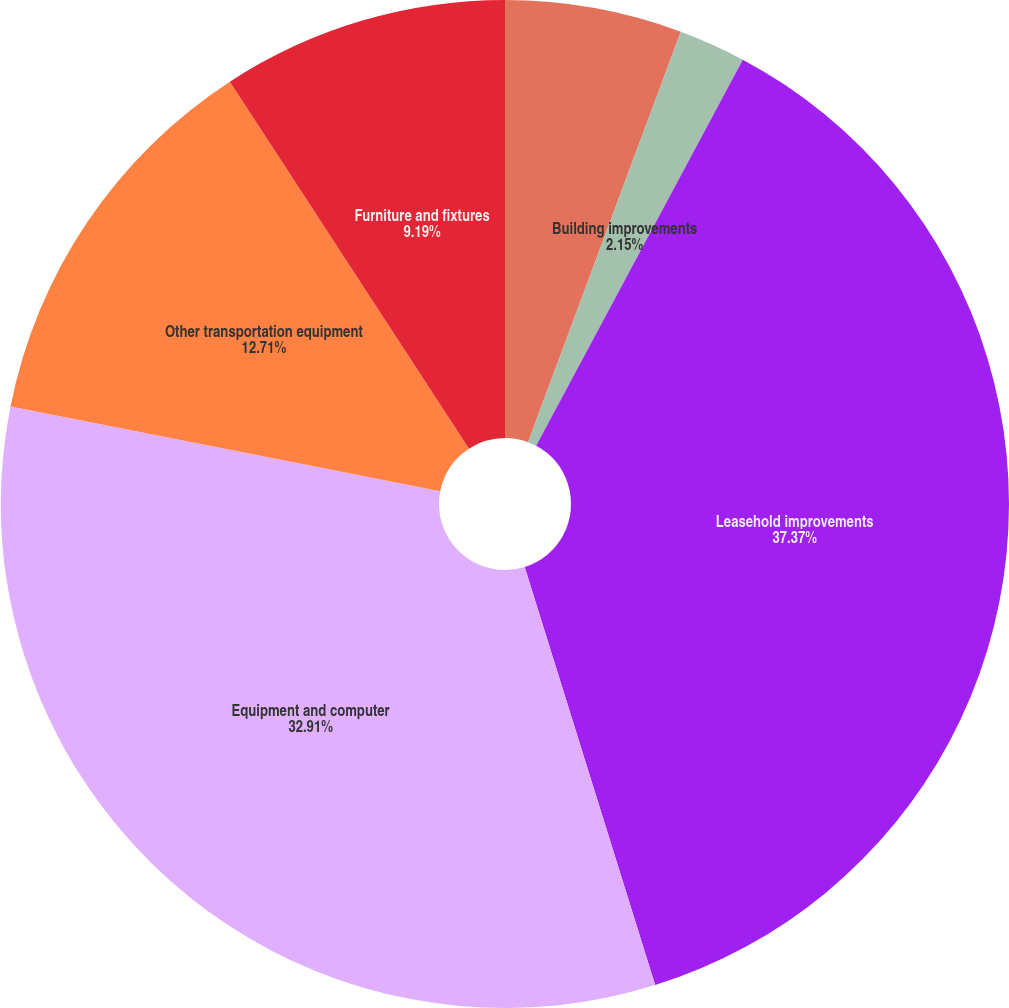<chart> <loc_0><loc_0><loc_500><loc_500><pie_chart><fcel>Building<fcel>Building improvements<fcel>Leasehold improvements<fcel>Equipment and computer<fcel>Other transportation equipment<fcel>Furniture and fixtures<nl><fcel>5.67%<fcel>2.15%<fcel>37.36%<fcel>32.91%<fcel>12.71%<fcel>9.19%<nl></chart> 